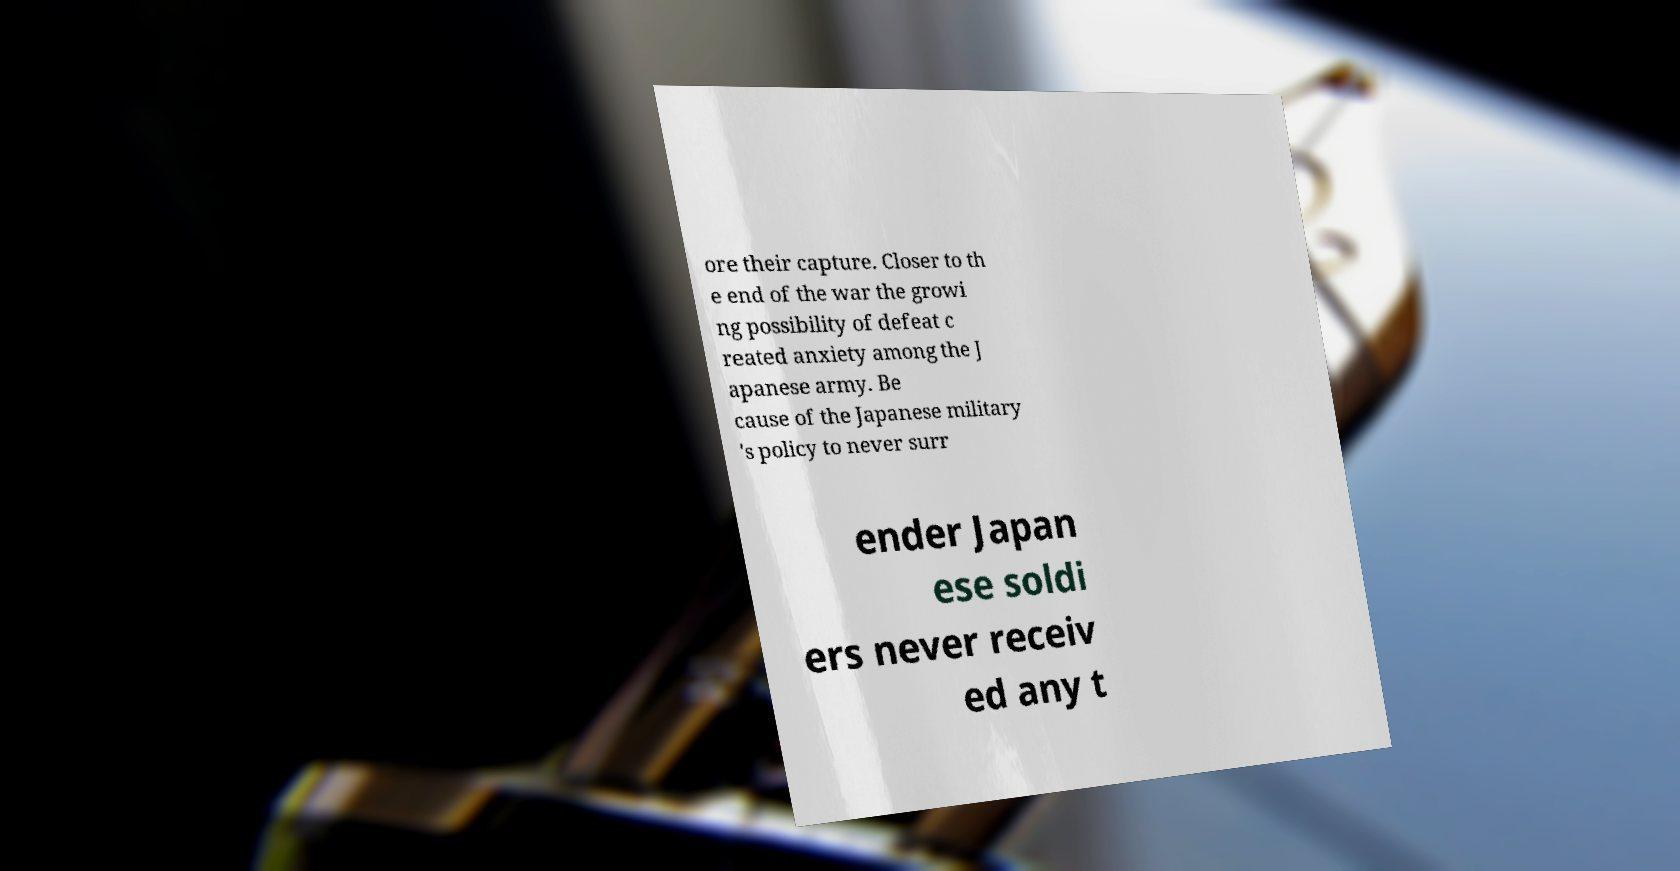I need the written content from this picture converted into text. Can you do that? ore their capture. Closer to th e end of the war the growi ng possibility of defeat c reated anxiety among the J apanese army. Be cause of the Japanese military 's policy to never surr ender Japan ese soldi ers never receiv ed any t 